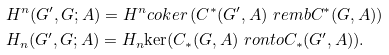<formula> <loc_0><loc_0><loc_500><loc_500>& H ^ { n } ( G ^ { \prime } , G ; A ) = H ^ { n } c o k e r \, ( C ^ { * } ( G ^ { \prime } , A ) \ r e m b C ^ { * } ( G , A ) ) \\ & H _ { n } ( G ^ { \prime } , G ; A ) = H _ { n } { \ker } ( C _ { * } ( G , A ) \ r o n t o C _ { * } ( G ^ { \prime } , A ) ) .</formula> 